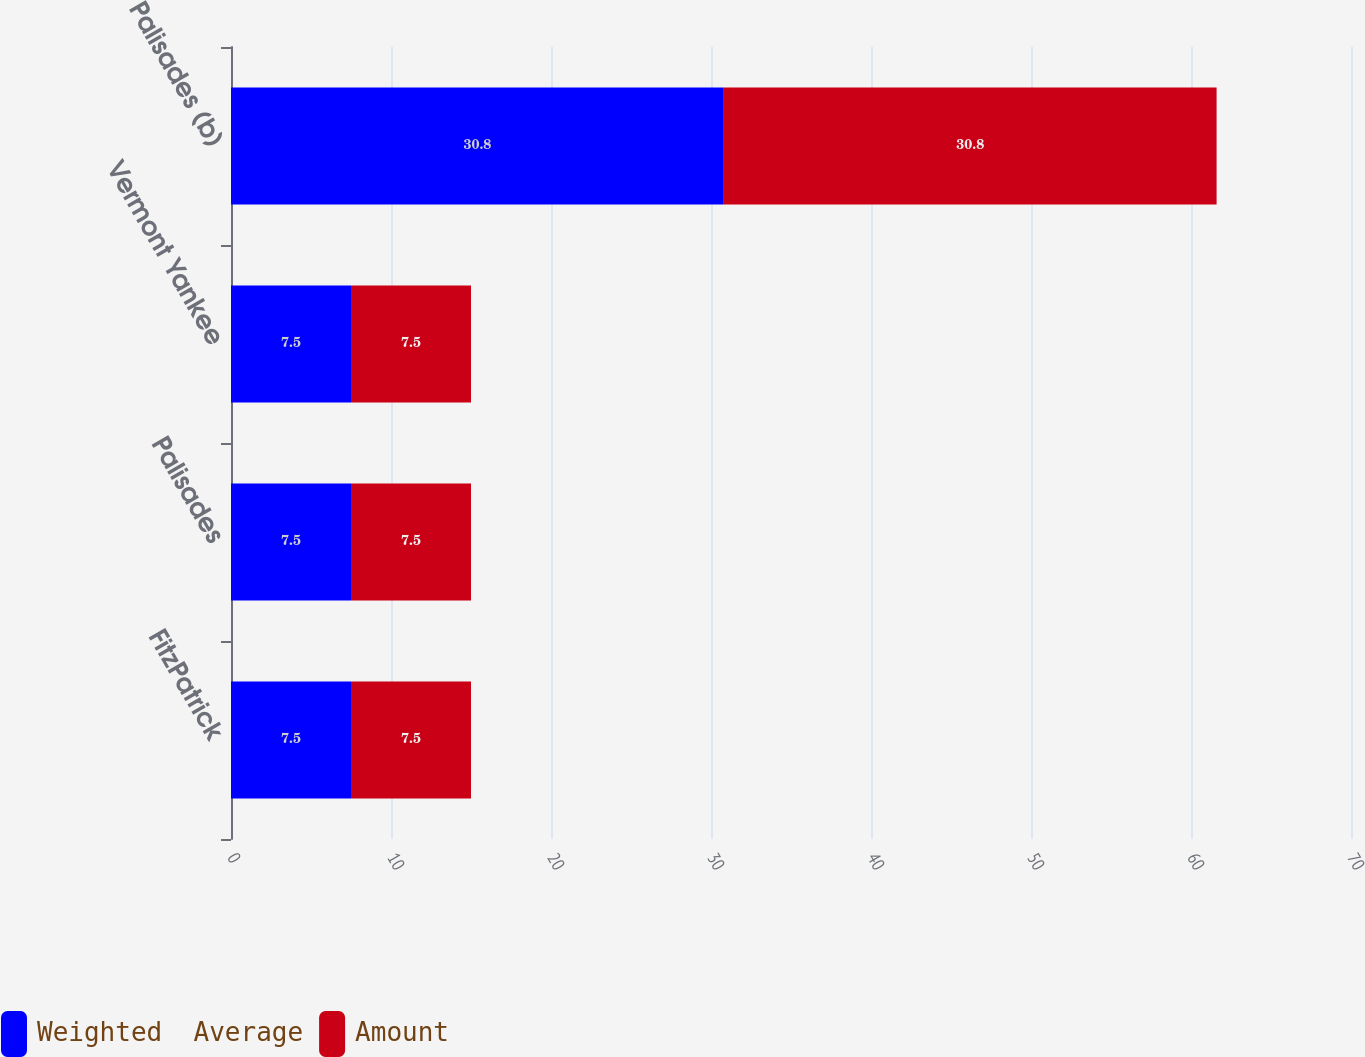Convert chart to OTSL. <chart><loc_0><loc_0><loc_500><loc_500><stacked_bar_chart><ecel><fcel>FitzPatrick<fcel>Palisades<fcel>Vermont Yankee<fcel>Palisades (b)<nl><fcel>Weighted  Average<fcel>7.5<fcel>7.5<fcel>7.5<fcel>30.8<nl><fcel>Amount<fcel>7.5<fcel>7.5<fcel>7.5<fcel>30.8<nl></chart> 